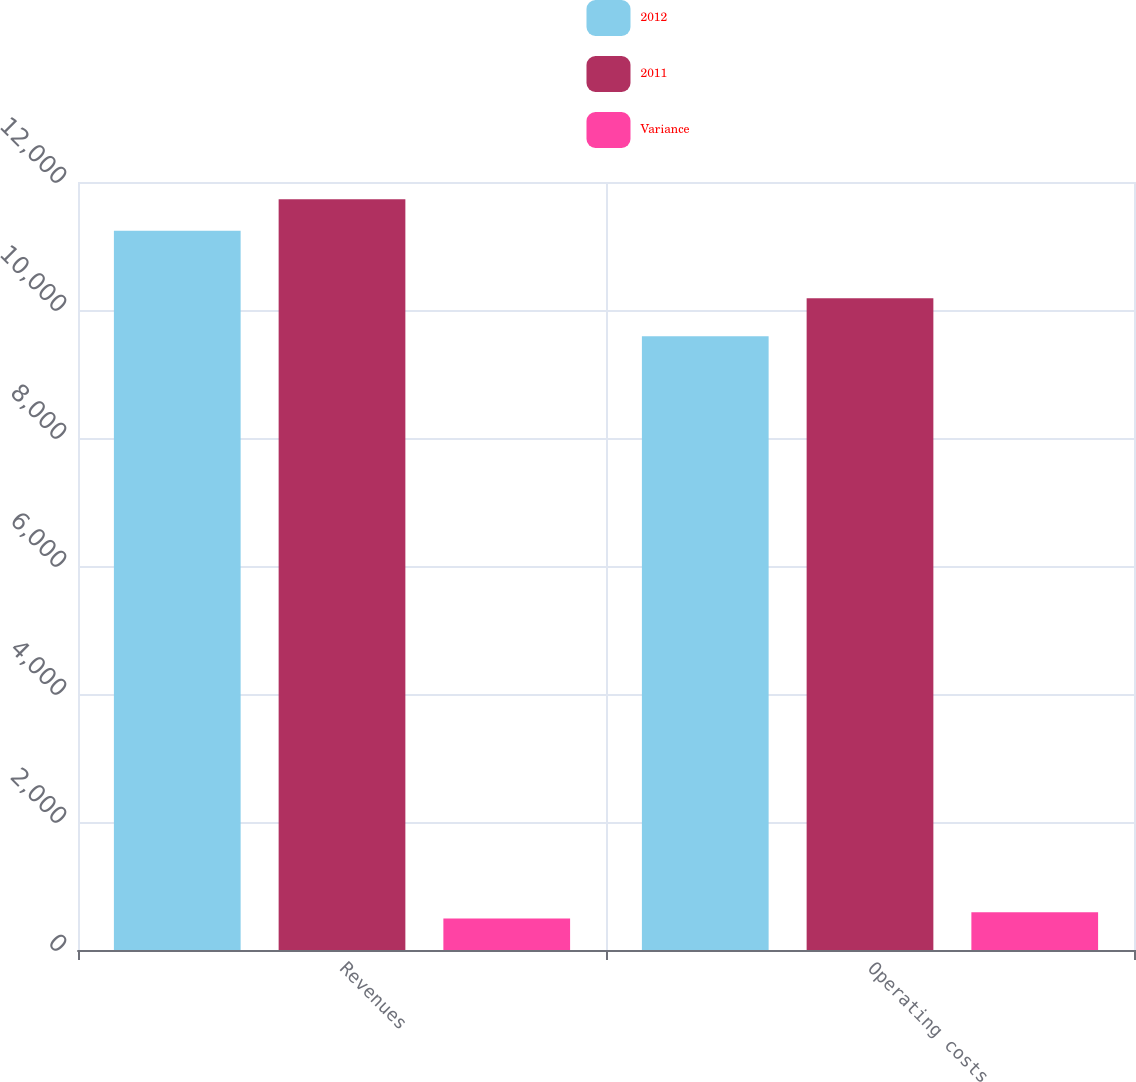<chart> <loc_0><loc_0><loc_500><loc_500><stacked_bar_chart><ecel><fcel>Revenues<fcel>Operating costs<nl><fcel>2012<fcel>11237<fcel>9591<nl><fcel>2011<fcel>11729<fcel>10182<nl><fcel>Variance<fcel>492<fcel>591<nl></chart> 